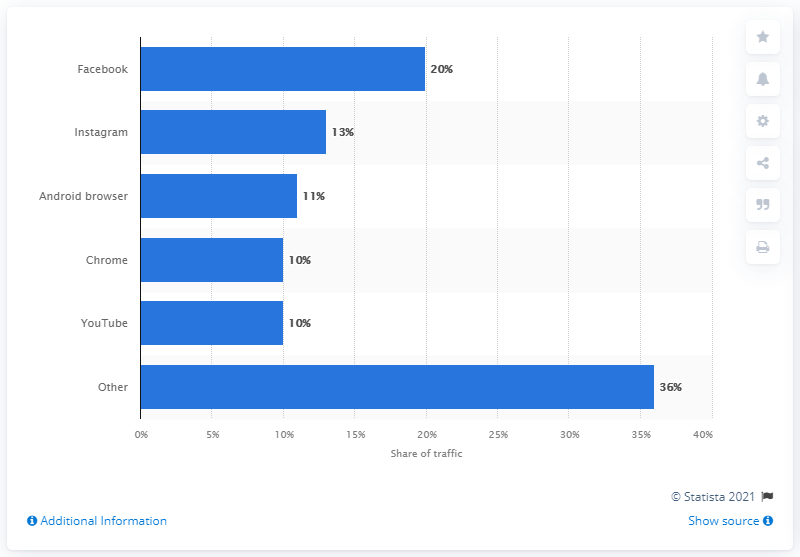Specify some key components in this picture. According to data, Facebook accounted for 20% of all mobile app traffic. 